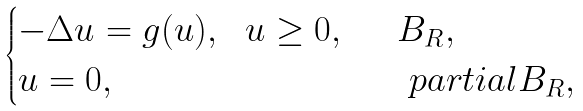Convert formula to latex. <formula><loc_0><loc_0><loc_500><loc_500>\begin{cases} - \Delta u = g ( u ) , \ \ u \geq 0 , & \ \ B _ { R } , \\ u = 0 , \ \ & \quad p a r t i a l B _ { R } , \end{cases}</formula> 